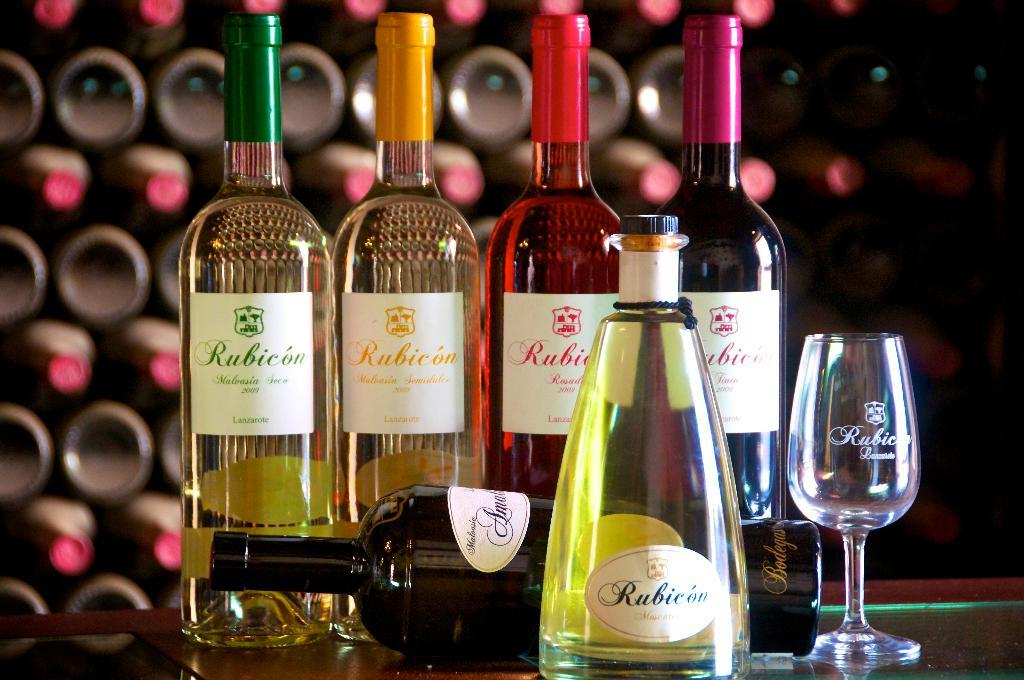<image>
Render a clear and concise summary of the photo. Different bottles of Rubicon wine sit on a bar counter next to an empty glass. 